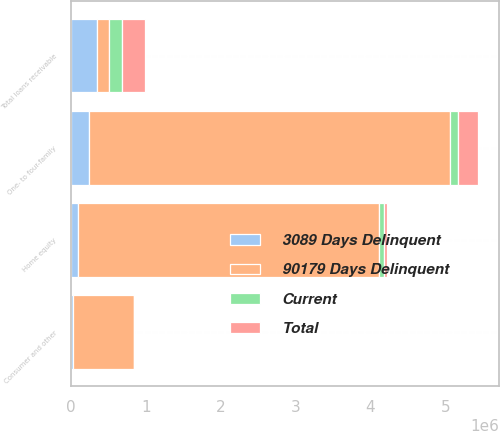Convert chart to OTSL. <chart><loc_0><loc_0><loc_500><loc_500><stacked_bar_chart><ecel><fcel>One- to four-family<fcel>Home equity<fcel>Consumer and other<fcel>Total loans receivable<nl><fcel>90179 Days Delinquent<fcel>4.83492e+06<fcel>4.02894e+06<fcel>819468<fcel>165069<nl><fcel>3089 Days Delinquent<fcel>233796<fcel>89347<fcel>19101<fcel>342244<nl><fcel>Current<fcel>94652<fcel>64239<fcel>6178<fcel>165069<nl><fcel>Total<fcel>278811<fcel>40939<fcel>195<fcel>319945<nl></chart> 